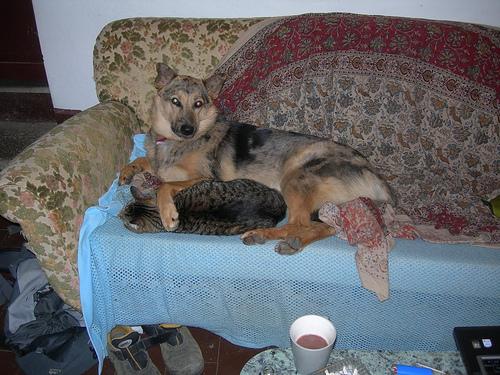What is the dog doing?
Give a very brief answer. Laying down. What color is the cup?
Quick response, please. White. What is printed on the couch?
Write a very short answer. Flowers. What is unique about the relationship between these two animals?
Quick response, please. Dog and cat. 